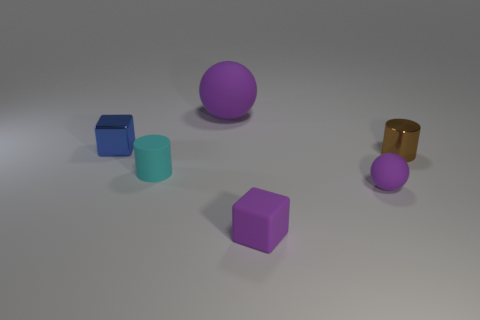Add 1 small brown metal things. How many objects exist? 7 Subtract all spheres. How many objects are left? 4 Subtract 1 cyan cylinders. How many objects are left? 5 Subtract all yellow cubes. Subtract all purple things. How many objects are left? 3 Add 2 shiny cylinders. How many shiny cylinders are left? 3 Add 2 purple balls. How many purple balls exist? 4 